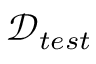Convert formula to latex. <formula><loc_0><loc_0><loc_500><loc_500>\mathcal { D } _ { t e s t }</formula> 